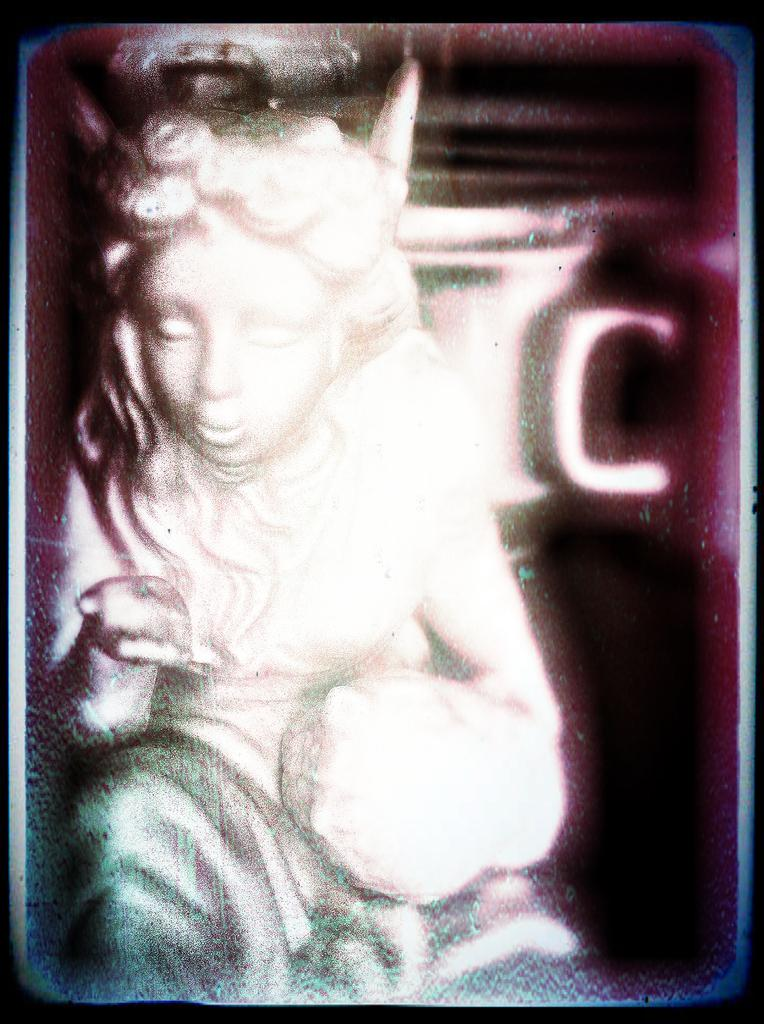What is the main subject of the image? There is a statue in the image. Can you describe the background of the image? The background of the image is blurred. What type of knot is tied around the statue in the image? There is no knot present around the statue in the image. What color is the silk fabric draped over the statue in the image? There is no silk fabric or any fabric draped over the statue in the image. 